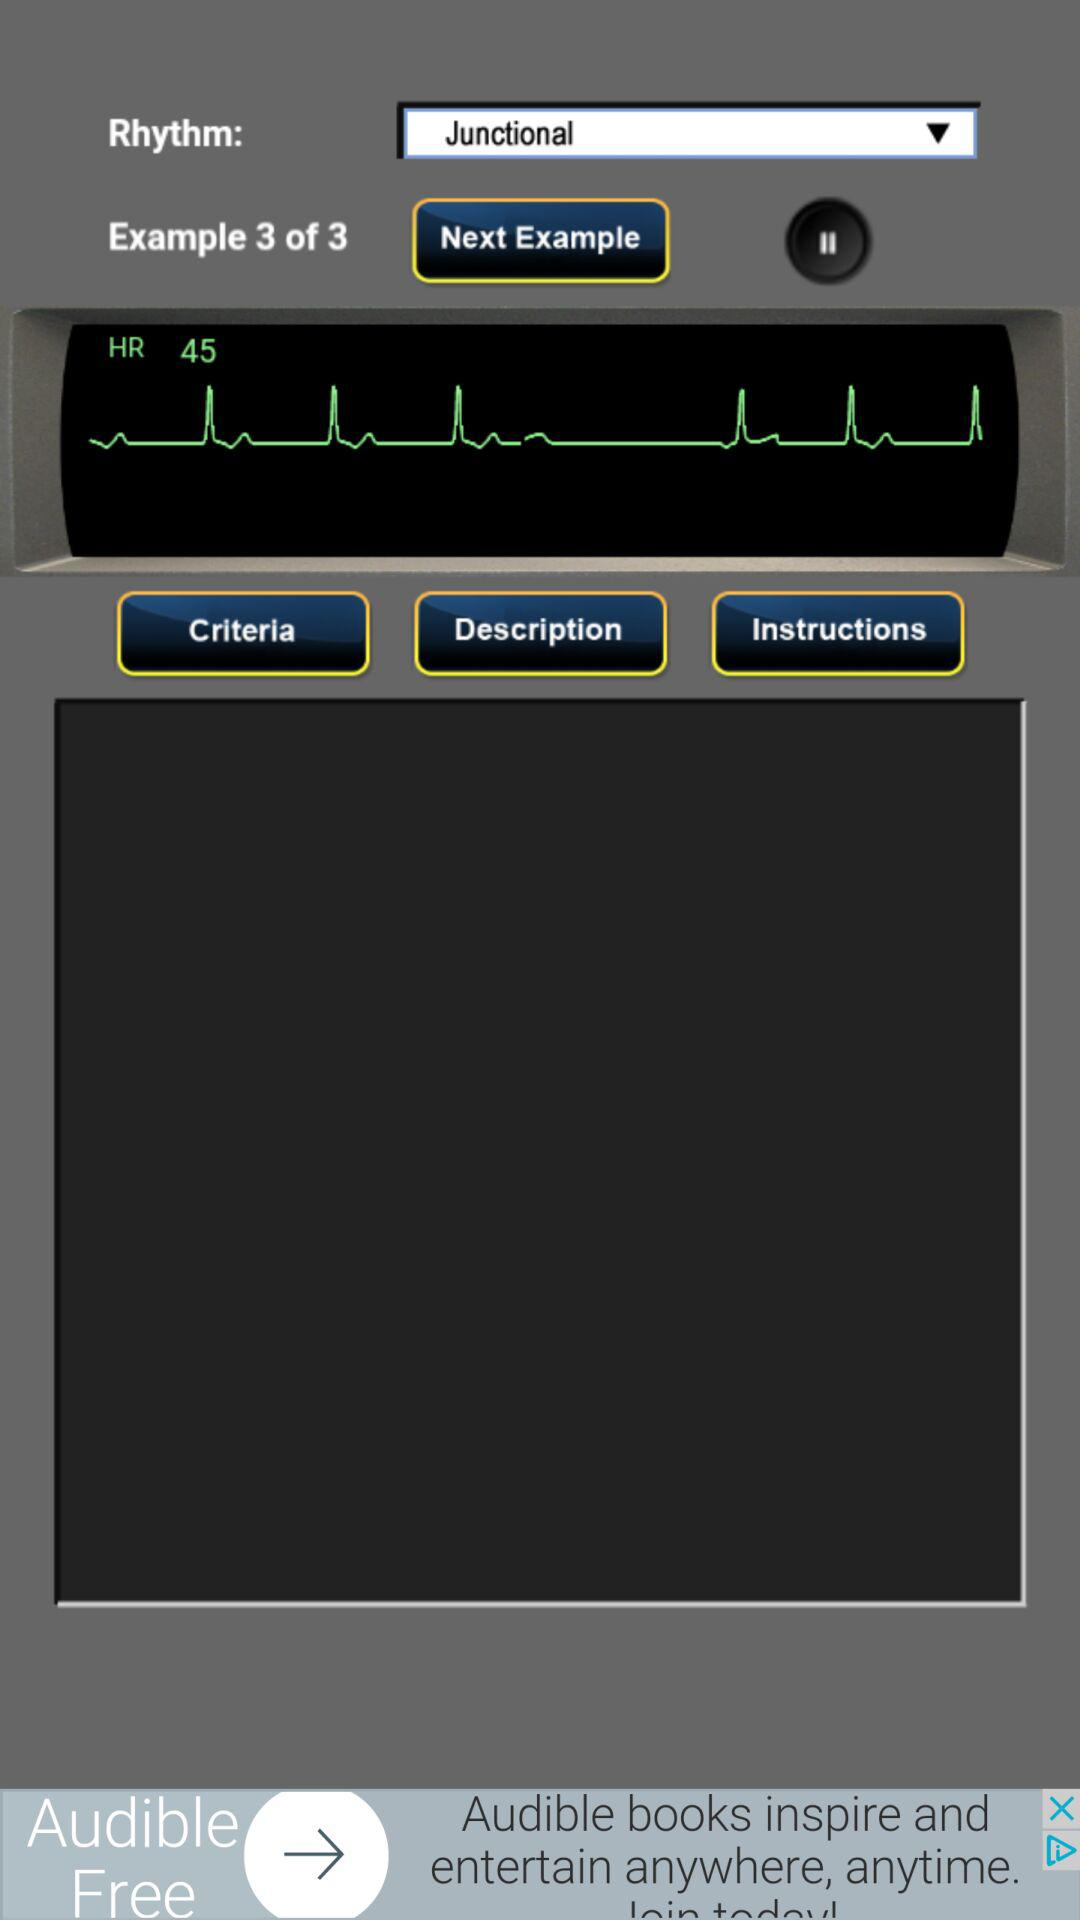Which rhythm has been selected? The selected rhythm is "Junctional". 